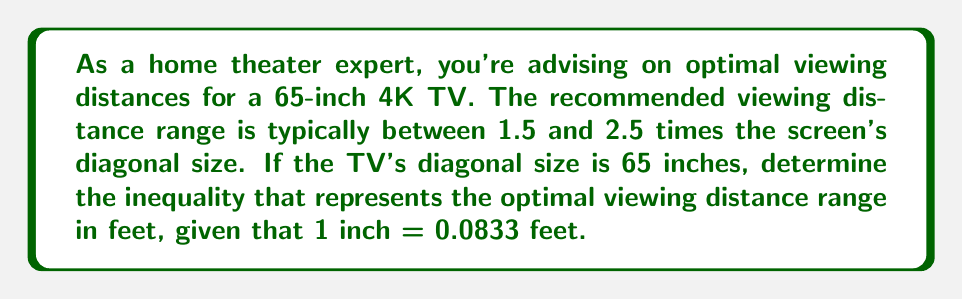Show me your answer to this math problem. Let's approach this step-by-step:

1) First, we need to convert the TV's diagonal size from inches to feet:
   $65 \text{ inches} \times 0.0833 \text{ feet/inch} = 5.4145 \text{ feet}$

2) Now, we can set up our inequality based on the given information:
   The viewing distance should be between 1.5 and 2.5 times the screen's diagonal size.

3) Let $x$ be the viewing distance in feet. We can express this as:
   $1.5 \times 5.4145 \leq x \leq 2.5 \times 5.4145$

4) Let's simplify by multiplying:
   $8.12175 \leq x \leq 13.53625$

5) Rounding to two decimal places for practicality:
   $8.12 \leq x \leq 13.54$

Therefore, the optimal viewing distance range in feet can be represented by the inequality:
$$8.12 \leq x \leq 13.54$$
where $x$ is the viewing distance in feet.
Answer: $8.12 \leq x \leq 13.54$, where $x$ is the viewing distance in feet. 